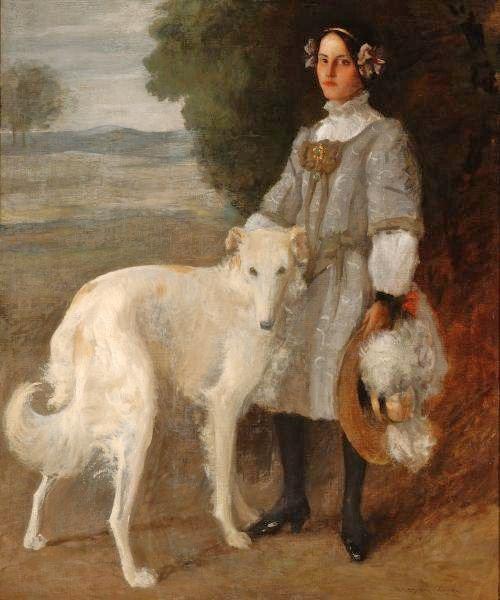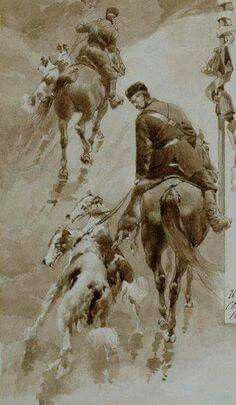The first image is the image on the left, the second image is the image on the right. For the images shown, is this caption "In at least one image there is a single female in a dress sit in a chair next to her white dog." true? Answer yes or no. No. The first image is the image on the left, the second image is the image on the right. For the images shown, is this caption "There is a woman sitting down with a dog next to her." true? Answer yes or no. No. 